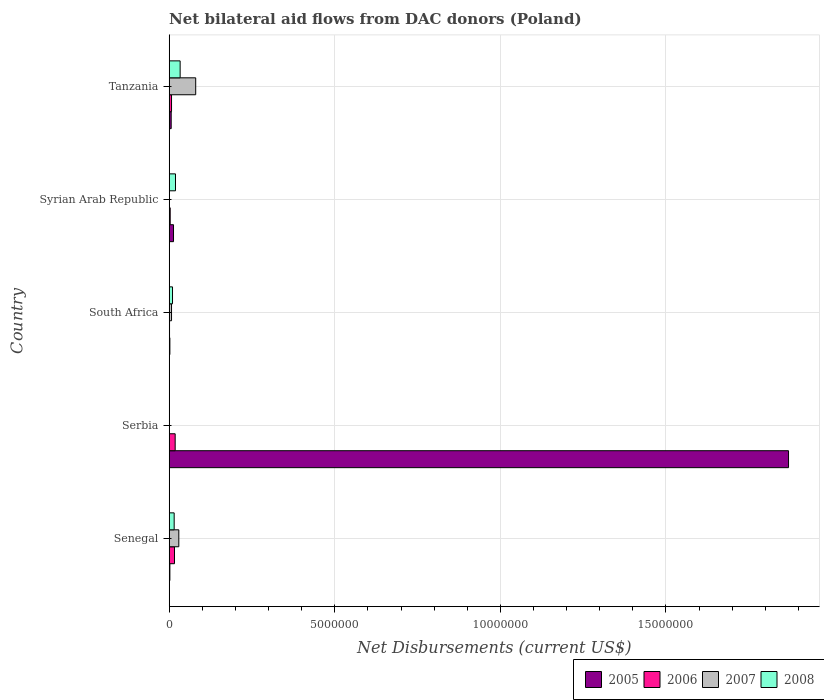How many different coloured bars are there?
Ensure brevity in your answer.  4. How many groups of bars are there?
Your answer should be very brief. 5. Are the number of bars per tick equal to the number of legend labels?
Your response must be concise. No. How many bars are there on the 3rd tick from the top?
Your answer should be very brief. 4. What is the label of the 1st group of bars from the top?
Keep it short and to the point. Tanzania. What is the net bilateral aid flows in 2006 in Serbia?
Ensure brevity in your answer.  1.80e+05. Across all countries, what is the maximum net bilateral aid flows in 2005?
Give a very brief answer. 1.87e+07. Across all countries, what is the minimum net bilateral aid flows in 2008?
Ensure brevity in your answer.  0. In which country was the net bilateral aid flows in 2008 maximum?
Offer a terse response. Tanzania. What is the difference between the net bilateral aid flows in 2005 in Serbia and that in Syrian Arab Republic?
Offer a very short reply. 1.86e+07. What is the average net bilateral aid flows in 2006 per country?
Offer a very short reply. 9.00e+04. What is the ratio of the net bilateral aid flows in 2007 in Senegal to that in South Africa?
Ensure brevity in your answer.  4.14. What is the difference between the highest and the lowest net bilateral aid flows in 2005?
Provide a short and direct response. 1.87e+07. Is it the case that in every country, the sum of the net bilateral aid flows in 2007 and net bilateral aid flows in 2008 is greater than the net bilateral aid flows in 2005?
Offer a terse response. No. How many bars are there?
Your response must be concise. 17. Does the graph contain any zero values?
Your answer should be compact. Yes. Where does the legend appear in the graph?
Ensure brevity in your answer.  Bottom right. How many legend labels are there?
Your response must be concise. 4. What is the title of the graph?
Give a very brief answer. Net bilateral aid flows from DAC donors (Poland). Does "1976" appear as one of the legend labels in the graph?
Your answer should be compact. No. What is the label or title of the X-axis?
Your answer should be compact. Net Disbursements (current US$). What is the Net Disbursements (current US$) of 2008 in Senegal?
Give a very brief answer. 1.50e+05. What is the Net Disbursements (current US$) of 2005 in Serbia?
Your answer should be compact. 1.87e+07. What is the Net Disbursements (current US$) in 2007 in Serbia?
Provide a succinct answer. 0. What is the Net Disbursements (current US$) in 2008 in South Africa?
Offer a terse response. 1.00e+05. What is the Net Disbursements (current US$) in 2008 in Syrian Arab Republic?
Give a very brief answer. 1.90e+05. What is the Net Disbursements (current US$) of 2005 in Tanzania?
Keep it short and to the point. 6.00e+04. What is the Net Disbursements (current US$) in 2006 in Tanzania?
Make the answer very short. 7.00e+04. What is the Net Disbursements (current US$) in 2008 in Tanzania?
Your answer should be very brief. 3.30e+05. Across all countries, what is the maximum Net Disbursements (current US$) of 2005?
Your answer should be compact. 1.87e+07. Across all countries, what is the maximum Net Disbursements (current US$) in 2008?
Make the answer very short. 3.30e+05. Across all countries, what is the minimum Net Disbursements (current US$) in 2005?
Offer a terse response. 2.00e+04. Across all countries, what is the minimum Net Disbursements (current US$) of 2008?
Provide a short and direct response. 0. What is the total Net Disbursements (current US$) of 2005 in the graph?
Give a very brief answer. 1.89e+07. What is the total Net Disbursements (current US$) in 2006 in the graph?
Give a very brief answer. 4.50e+05. What is the total Net Disbursements (current US$) of 2007 in the graph?
Give a very brief answer. 1.16e+06. What is the total Net Disbursements (current US$) in 2008 in the graph?
Your answer should be compact. 7.70e+05. What is the difference between the Net Disbursements (current US$) of 2005 in Senegal and that in Serbia?
Make the answer very short. -1.87e+07. What is the difference between the Net Disbursements (current US$) in 2007 in Senegal and that in South Africa?
Provide a short and direct response. 2.20e+05. What is the difference between the Net Disbursements (current US$) in 2008 in Senegal and that in South Africa?
Provide a short and direct response. 5.00e+04. What is the difference between the Net Disbursements (current US$) in 2008 in Senegal and that in Syrian Arab Republic?
Give a very brief answer. -4.00e+04. What is the difference between the Net Disbursements (current US$) of 2005 in Senegal and that in Tanzania?
Your answer should be compact. -4.00e+04. What is the difference between the Net Disbursements (current US$) in 2006 in Senegal and that in Tanzania?
Make the answer very short. 9.00e+04. What is the difference between the Net Disbursements (current US$) in 2007 in Senegal and that in Tanzania?
Your answer should be compact. -5.10e+05. What is the difference between the Net Disbursements (current US$) of 2005 in Serbia and that in South Africa?
Ensure brevity in your answer.  1.87e+07. What is the difference between the Net Disbursements (current US$) of 2005 in Serbia and that in Syrian Arab Republic?
Your answer should be compact. 1.86e+07. What is the difference between the Net Disbursements (current US$) in 2006 in Serbia and that in Syrian Arab Republic?
Keep it short and to the point. 1.50e+05. What is the difference between the Net Disbursements (current US$) in 2005 in Serbia and that in Tanzania?
Ensure brevity in your answer.  1.86e+07. What is the difference between the Net Disbursements (current US$) in 2006 in South Africa and that in Syrian Arab Republic?
Offer a very short reply. -2.00e+04. What is the difference between the Net Disbursements (current US$) in 2008 in South Africa and that in Syrian Arab Republic?
Your answer should be very brief. -9.00e+04. What is the difference between the Net Disbursements (current US$) in 2005 in South Africa and that in Tanzania?
Your answer should be compact. -4.00e+04. What is the difference between the Net Disbursements (current US$) in 2007 in South Africa and that in Tanzania?
Your answer should be very brief. -7.30e+05. What is the difference between the Net Disbursements (current US$) in 2006 in Senegal and the Net Disbursements (current US$) in 2008 in South Africa?
Ensure brevity in your answer.  6.00e+04. What is the difference between the Net Disbursements (current US$) in 2007 in Senegal and the Net Disbursements (current US$) in 2008 in South Africa?
Keep it short and to the point. 1.90e+05. What is the difference between the Net Disbursements (current US$) of 2005 in Senegal and the Net Disbursements (current US$) of 2006 in Syrian Arab Republic?
Your response must be concise. -10000. What is the difference between the Net Disbursements (current US$) in 2007 in Senegal and the Net Disbursements (current US$) in 2008 in Syrian Arab Republic?
Your answer should be compact. 1.00e+05. What is the difference between the Net Disbursements (current US$) in 2005 in Senegal and the Net Disbursements (current US$) in 2006 in Tanzania?
Offer a terse response. -5.00e+04. What is the difference between the Net Disbursements (current US$) of 2005 in Senegal and the Net Disbursements (current US$) of 2007 in Tanzania?
Make the answer very short. -7.80e+05. What is the difference between the Net Disbursements (current US$) of 2005 in Senegal and the Net Disbursements (current US$) of 2008 in Tanzania?
Provide a short and direct response. -3.10e+05. What is the difference between the Net Disbursements (current US$) in 2006 in Senegal and the Net Disbursements (current US$) in 2007 in Tanzania?
Provide a succinct answer. -6.40e+05. What is the difference between the Net Disbursements (current US$) in 2005 in Serbia and the Net Disbursements (current US$) in 2006 in South Africa?
Keep it short and to the point. 1.87e+07. What is the difference between the Net Disbursements (current US$) in 2005 in Serbia and the Net Disbursements (current US$) in 2007 in South Africa?
Provide a succinct answer. 1.86e+07. What is the difference between the Net Disbursements (current US$) of 2005 in Serbia and the Net Disbursements (current US$) of 2008 in South Africa?
Provide a short and direct response. 1.86e+07. What is the difference between the Net Disbursements (current US$) in 2006 in Serbia and the Net Disbursements (current US$) in 2008 in South Africa?
Give a very brief answer. 8.00e+04. What is the difference between the Net Disbursements (current US$) in 2005 in Serbia and the Net Disbursements (current US$) in 2006 in Syrian Arab Republic?
Ensure brevity in your answer.  1.87e+07. What is the difference between the Net Disbursements (current US$) of 2005 in Serbia and the Net Disbursements (current US$) of 2008 in Syrian Arab Republic?
Offer a terse response. 1.85e+07. What is the difference between the Net Disbursements (current US$) of 2005 in Serbia and the Net Disbursements (current US$) of 2006 in Tanzania?
Give a very brief answer. 1.86e+07. What is the difference between the Net Disbursements (current US$) in 2005 in Serbia and the Net Disbursements (current US$) in 2007 in Tanzania?
Provide a short and direct response. 1.79e+07. What is the difference between the Net Disbursements (current US$) of 2005 in Serbia and the Net Disbursements (current US$) of 2008 in Tanzania?
Your answer should be very brief. 1.84e+07. What is the difference between the Net Disbursements (current US$) of 2006 in Serbia and the Net Disbursements (current US$) of 2007 in Tanzania?
Provide a short and direct response. -6.20e+05. What is the difference between the Net Disbursements (current US$) of 2005 in South Africa and the Net Disbursements (current US$) of 2008 in Syrian Arab Republic?
Make the answer very short. -1.70e+05. What is the difference between the Net Disbursements (current US$) of 2005 in South Africa and the Net Disbursements (current US$) of 2007 in Tanzania?
Offer a terse response. -7.80e+05. What is the difference between the Net Disbursements (current US$) of 2005 in South Africa and the Net Disbursements (current US$) of 2008 in Tanzania?
Provide a short and direct response. -3.10e+05. What is the difference between the Net Disbursements (current US$) of 2006 in South Africa and the Net Disbursements (current US$) of 2007 in Tanzania?
Your answer should be very brief. -7.90e+05. What is the difference between the Net Disbursements (current US$) in 2006 in South Africa and the Net Disbursements (current US$) in 2008 in Tanzania?
Your answer should be very brief. -3.20e+05. What is the difference between the Net Disbursements (current US$) of 2007 in South Africa and the Net Disbursements (current US$) of 2008 in Tanzania?
Provide a succinct answer. -2.60e+05. What is the difference between the Net Disbursements (current US$) of 2005 in Syrian Arab Republic and the Net Disbursements (current US$) of 2007 in Tanzania?
Offer a very short reply. -6.70e+05. What is the difference between the Net Disbursements (current US$) in 2006 in Syrian Arab Republic and the Net Disbursements (current US$) in 2007 in Tanzania?
Keep it short and to the point. -7.70e+05. What is the average Net Disbursements (current US$) in 2005 per country?
Ensure brevity in your answer.  3.79e+06. What is the average Net Disbursements (current US$) in 2007 per country?
Your answer should be very brief. 2.32e+05. What is the average Net Disbursements (current US$) of 2008 per country?
Ensure brevity in your answer.  1.54e+05. What is the difference between the Net Disbursements (current US$) of 2007 and Net Disbursements (current US$) of 2008 in Senegal?
Provide a short and direct response. 1.40e+05. What is the difference between the Net Disbursements (current US$) in 2005 and Net Disbursements (current US$) in 2006 in Serbia?
Keep it short and to the point. 1.85e+07. What is the difference between the Net Disbursements (current US$) of 2005 and Net Disbursements (current US$) of 2007 in South Africa?
Offer a very short reply. -5.00e+04. What is the difference between the Net Disbursements (current US$) of 2005 and Net Disbursements (current US$) of 2008 in South Africa?
Offer a very short reply. -8.00e+04. What is the difference between the Net Disbursements (current US$) in 2007 and Net Disbursements (current US$) in 2008 in South Africa?
Your response must be concise. -3.00e+04. What is the difference between the Net Disbursements (current US$) in 2005 and Net Disbursements (current US$) in 2007 in Tanzania?
Ensure brevity in your answer.  -7.40e+05. What is the difference between the Net Disbursements (current US$) of 2006 and Net Disbursements (current US$) of 2007 in Tanzania?
Your response must be concise. -7.30e+05. What is the difference between the Net Disbursements (current US$) of 2006 and Net Disbursements (current US$) of 2008 in Tanzania?
Your answer should be very brief. -2.60e+05. What is the difference between the Net Disbursements (current US$) in 2007 and Net Disbursements (current US$) in 2008 in Tanzania?
Keep it short and to the point. 4.70e+05. What is the ratio of the Net Disbursements (current US$) in 2005 in Senegal to that in Serbia?
Keep it short and to the point. 0. What is the ratio of the Net Disbursements (current US$) of 2006 in Senegal to that in South Africa?
Your answer should be very brief. 16. What is the ratio of the Net Disbursements (current US$) of 2007 in Senegal to that in South Africa?
Provide a short and direct response. 4.14. What is the ratio of the Net Disbursements (current US$) in 2005 in Senegal to that in Syrian Arab Republic?
Offer a terse response. 0.15. What is the ratio of the Net Disbursements (current US$) of 2006 in Senegal to that in Syrian Arab Republic?
Make the answer very short. 5.33. What is the ratio of the Net Disbursements (current US$) in 2008 in Senegal to that in Syrian Arab Republic?
Give a very brief answer. 0.79. What is the ratio of the Net Disbursements (current US$) in 2006 in Senegal to that in Tanzania?
Make the answer very short. 2.29. What is the ratio of the Net Disbursements (current US$) of 2007 in Senegal to that in Tanzania?
Your answer should be compact. 0.36. What is the ratio of the Net Disbursements (current US$) in 2008 in Senegal to that in Tanzania?
Provide a short and direct response. 0.45. What is the ratio of the Net Disbursements (current US$) in 2005 in Serbia to that in South Africa?
Give a very brief answer. 935. What is the ratio of the Net Disbursements (current US$) in 2006 in Serbia to that in South Africa?
Give a very brief answer. 18. What is the ratio of the Net Disbursements (current US$) of 2005 in Serbia to that in Syrian Arab Republic?
Your answer should be compact. 143.85. What is the ratio of the Net Disbursements (current US$) of 2005 in Serbia to that in Tanzania?
Offer a terse response. 311.67. What is the ratio of the Net Disbursements (current US$) of 2006 in Serbia to that in Tanzania?
Keep it short and to the point. 2.57. What is the ratio of the Net Disbursements (current US$) in 2005 in South Africa to that in Syrian Arab Republic?
Provide a succinct answer. 0.15. What is the ratio of the Net Disbursements (current US$) of 2006 in South Africa to that in Syrian Arab Republic?
Your response must be concise. 0.33. What is the ratio of the Net Disbursements (current US$) of 2008 in South Africa to that in Syrian Arab Republic?
Offer a terse response. 0.53. What is the ratio of the Net Disbursements (current US$) of 2006 in South Africa to that in Tanzania?
Give a very brief answer. 0.14. What is the ratio of the Net Disbursements (current US$) of 2007 in South Africa to that in Tanzania?
Your answer should be very brief. 0.09. What is the ratio of the Net Disbursements (current US$) in 2008 in South Africa to that in Tanzania?
Provide a succinct answer. 0.3. What is the ratio of the Net Disbursements (current US$) in 2005 in Syrian Arab Republic to that in Tanzania?
Offer a terse response. 2.17. What is the ratio of the Net Disbursements (current US$) in 2006 in Syrian Arab Republic to that in Tanzania?
Keep it short and to the point. 0.43. What is the ratio of the Net Disbursements (current US$) in 2008 in Syrian Arab Republic to that in Tanzania?
Give a very brief answer. 0.58. What is the difference between the highest and the second highest Net Disbursements (current US$) in 2005?
Ensure brevity in your answer.  1.86e+07. What is the difference between the highest and the second highest Net Disbursements (current US$) in 2007?
Your answer should be compact. 5.10e+05. What is the difference between the highest and the second highest Net Disbursements (current US$) of 2008?
Ensure brevity in your answer.  1.40e+05. What is the difference between the highest and the lowest Net Disbursements (current US$) of 2005?
Offer a very short reply. 1.87e+07. What is the difference between the highest and the lowest Net Disbursements (current US$) of 2006?
Provide a short and direct response. 1.70e+05. What is the difference between the highest and the lowest Net Disbursements (current US$) in 2008?
Your answer should be very brief. 3.30e+05. 